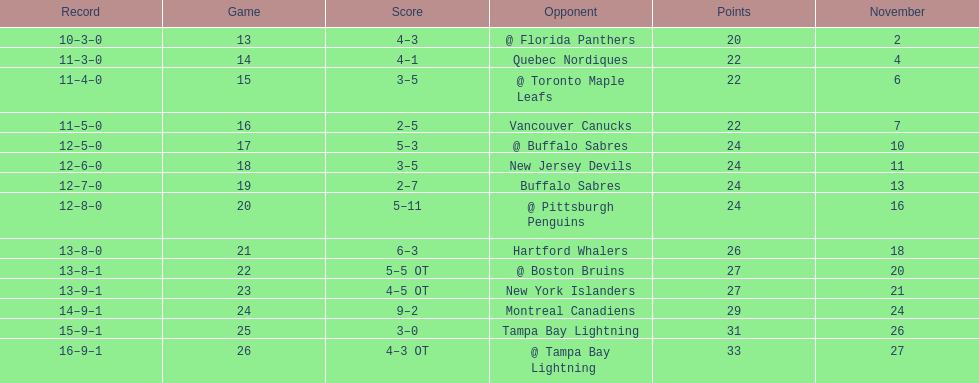Who had the most assists on the 1993-1994 flyers? Mark Recchi. 